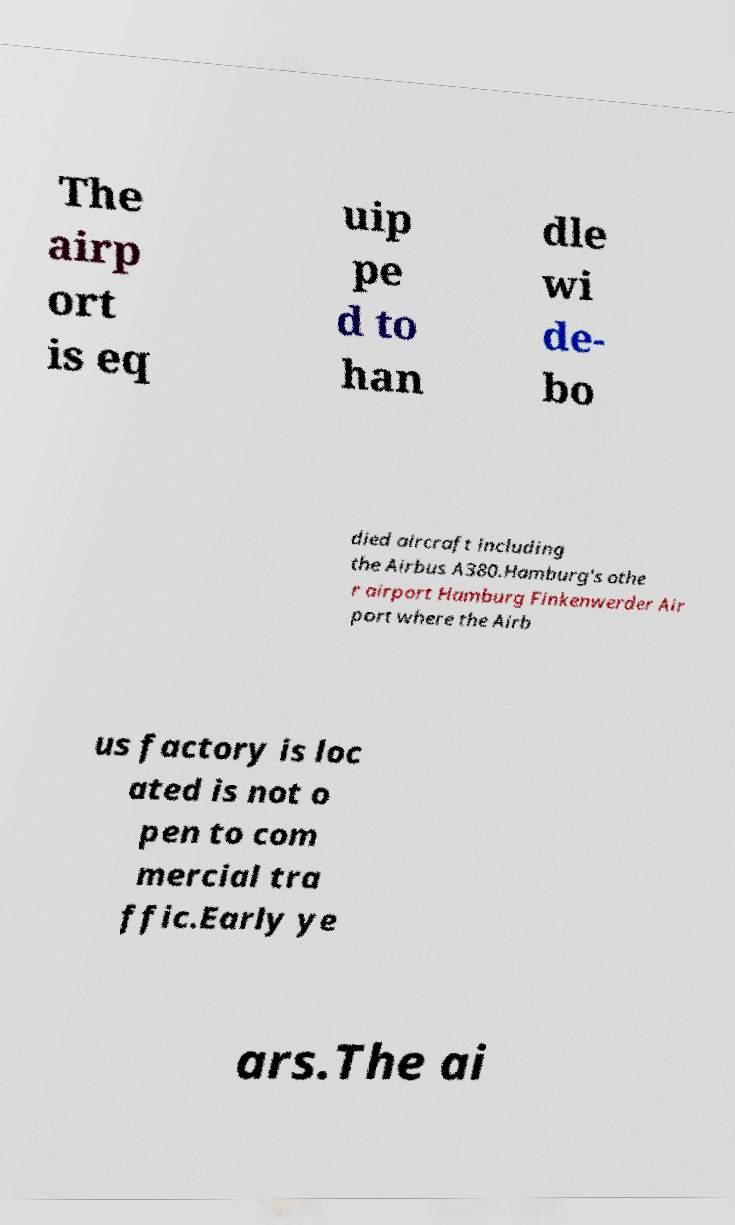Can you read and provide the text displayed in the image?This photo seems to have some interesting text. Can you extract and type it out for me? The airp ort is eq uip pe d to han dle wi de- bo died aircraft including the Airbus A380.Hamburg's othe r airport Hamburg Finkenwerder Air port where the Airb us factory is loc ated is not o pen to com mercial tra ffic.Early ye ars.The ai 